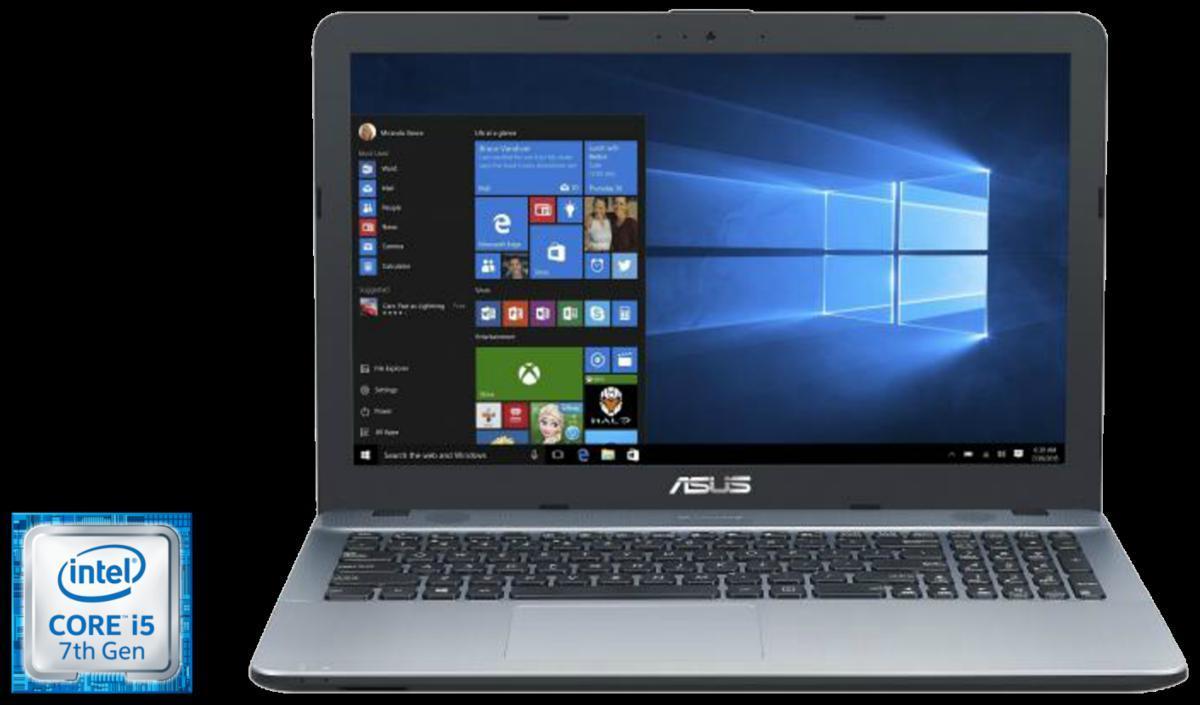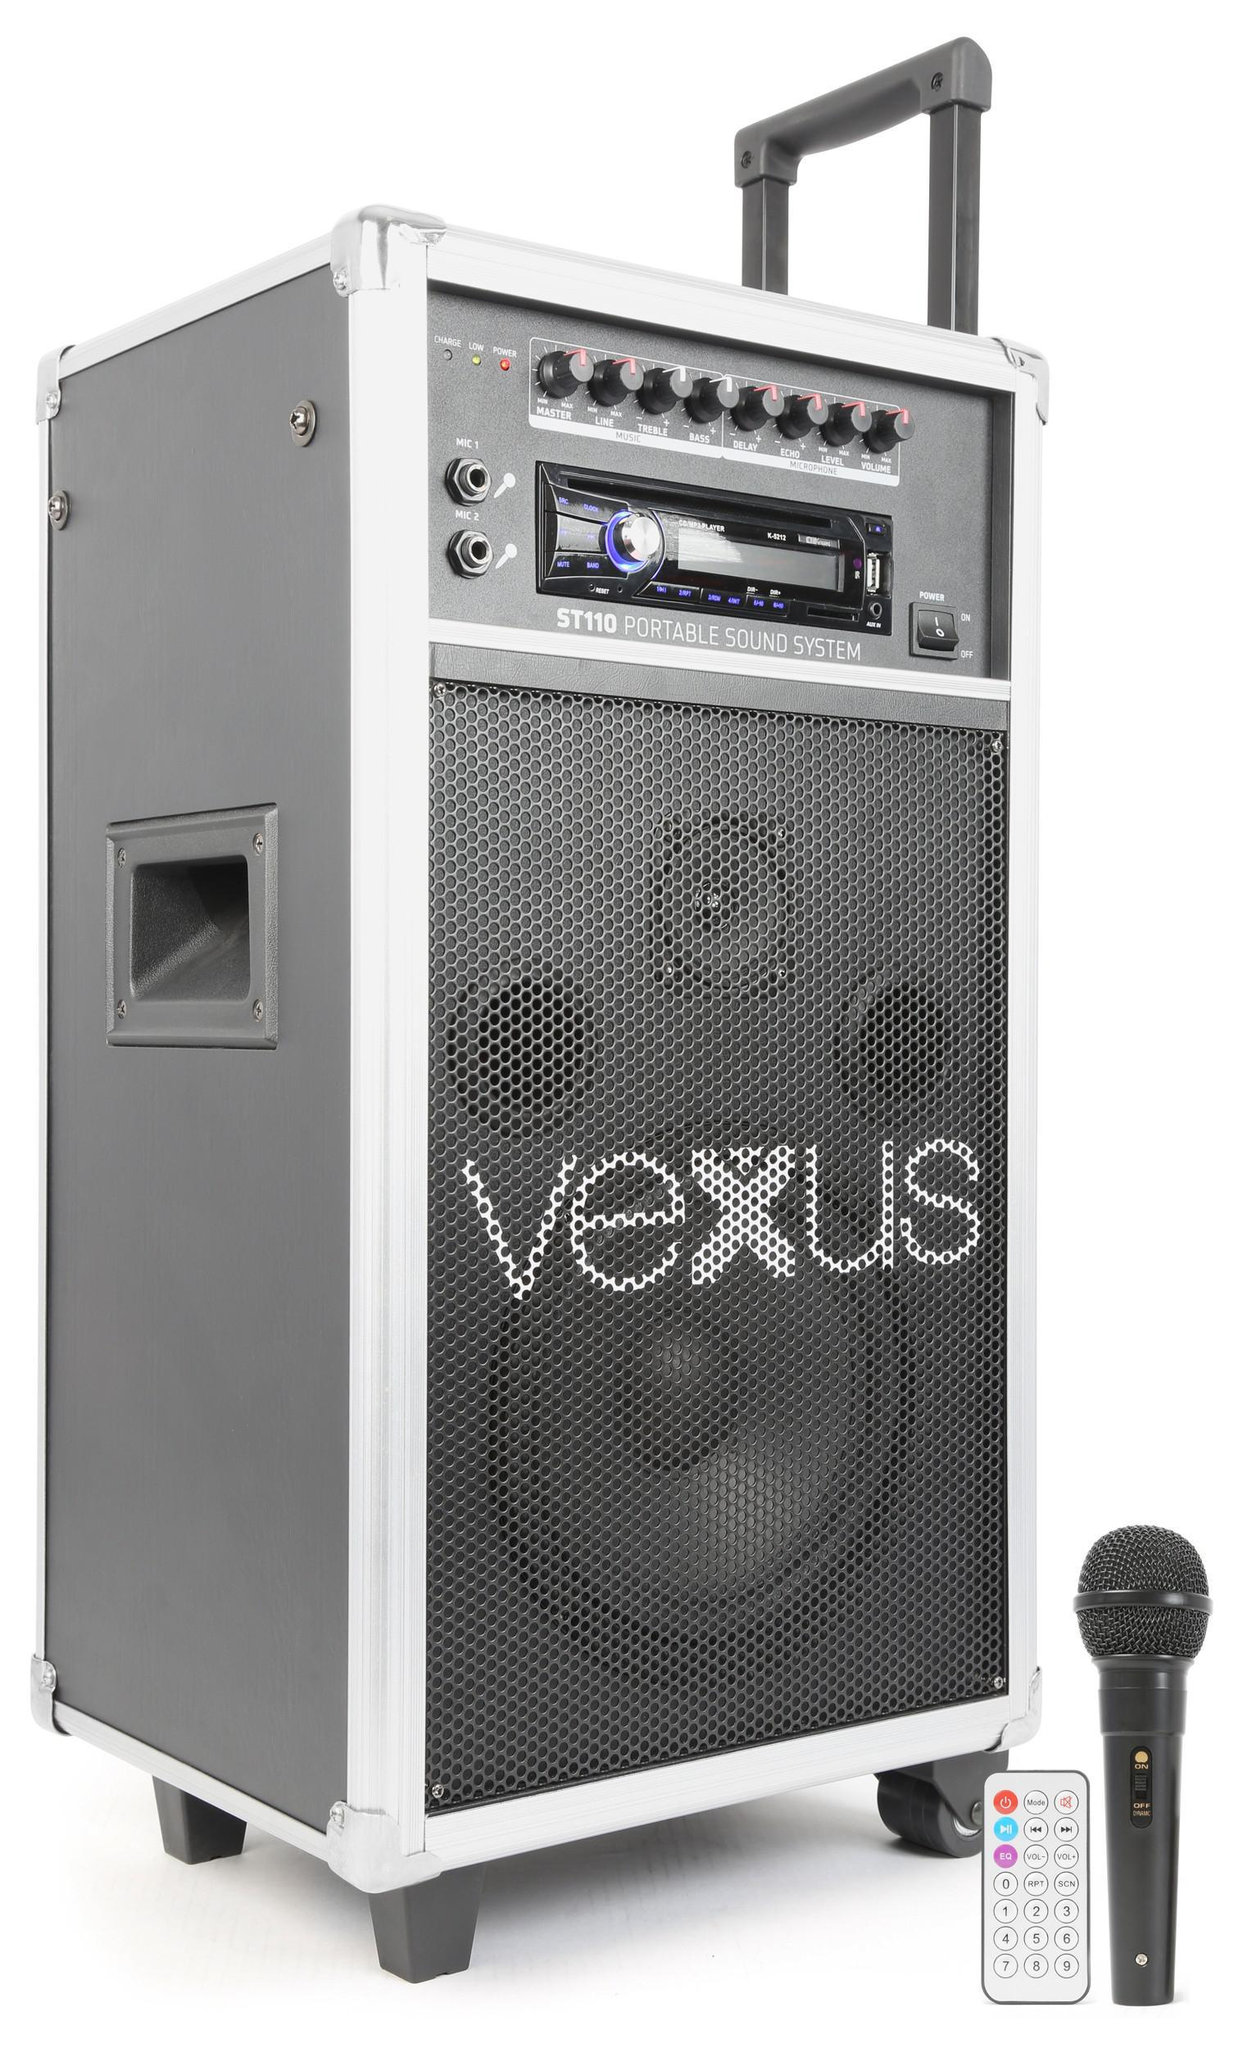The first image is the image on the left, the second image is the image on the right. For the images displayed, is the sentence "An open gold-toned laptop computer is shown in one image." factually correct? Answer yes or no. No. The first image is the image on the left, the second image is the image on the right. For the images displayed, is the sentence "One image shows a laptop with a woman's face predominant on the screen." factually correct? Answer yes or no. No. 